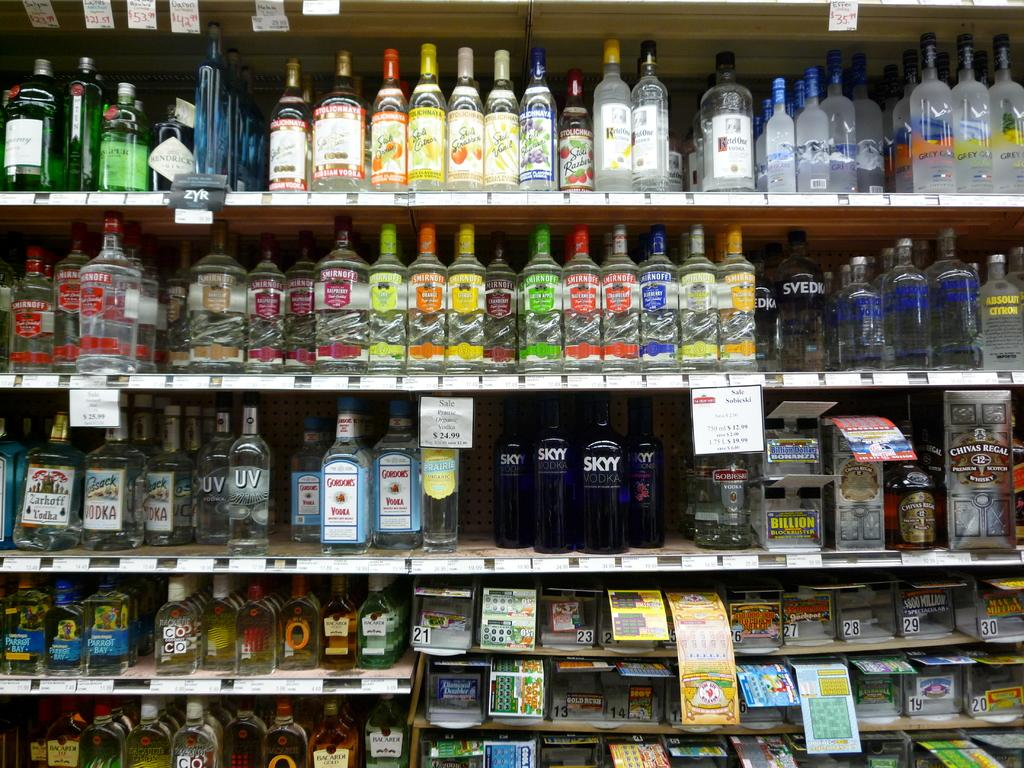What objects are in the foreground of the image? There are many bottles and boxes in the foreground of the image. How are the bottles and boxes arranged in the image? The bottles and boxes are in a rack. Are there any labels or markings on the bottles and boxes? Yes, price tags are attached to the bottles and boxes. What type of frame is visible around the bottles and boxes in the image? There is no frame visible around the bottles and boxes in the image. Can you tell me what type of office supplies are present in the image? The image does not show any office supplies; it only features bottles and boxes in a rack with price tags. 